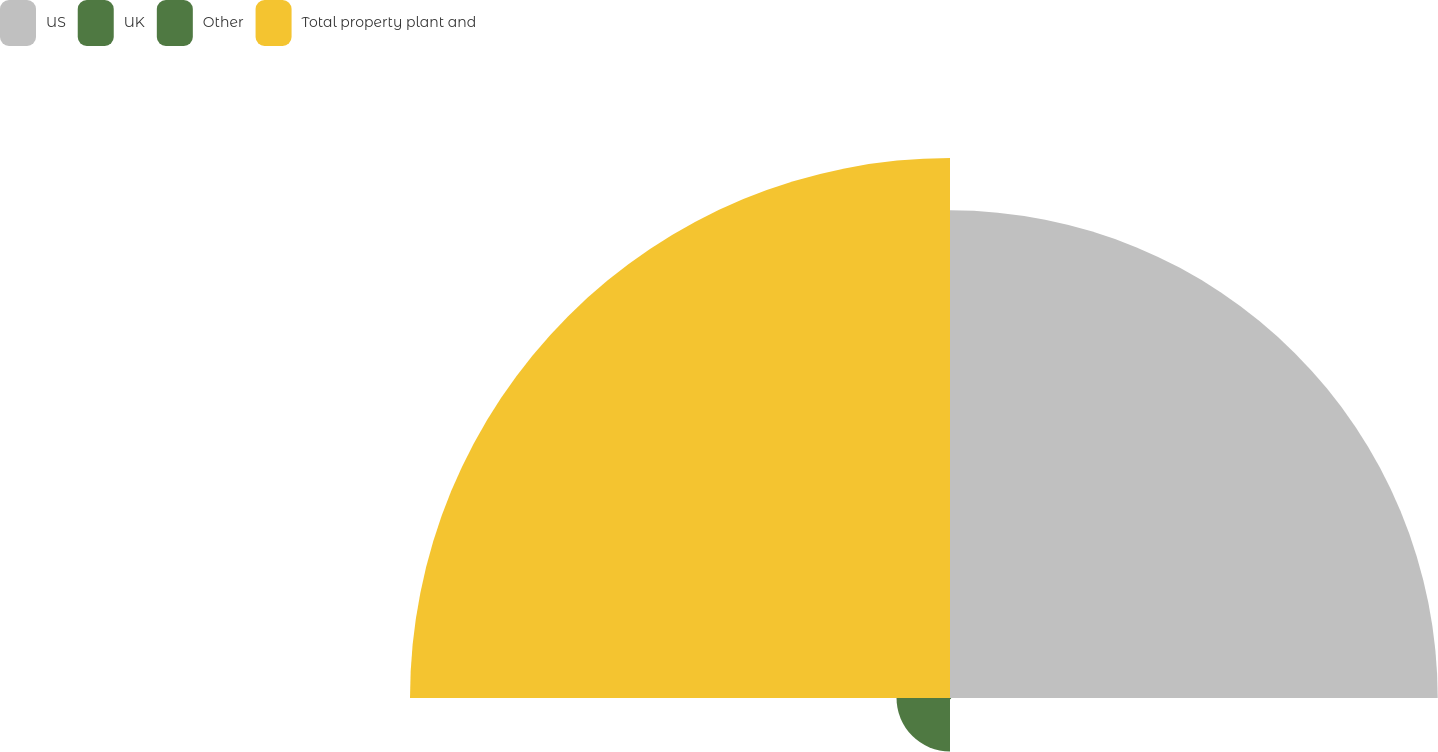Convert chart. <chart><loc_0><loc_0><loc_500><loc_500><pie_chart><fcel>US<fcel>UK<fcel>Other<fcel>Total property plant and<nl><fcel>45.06%<fcel>0.11%<fcel>4.94%<fcel>49.89%<nl></chart> 